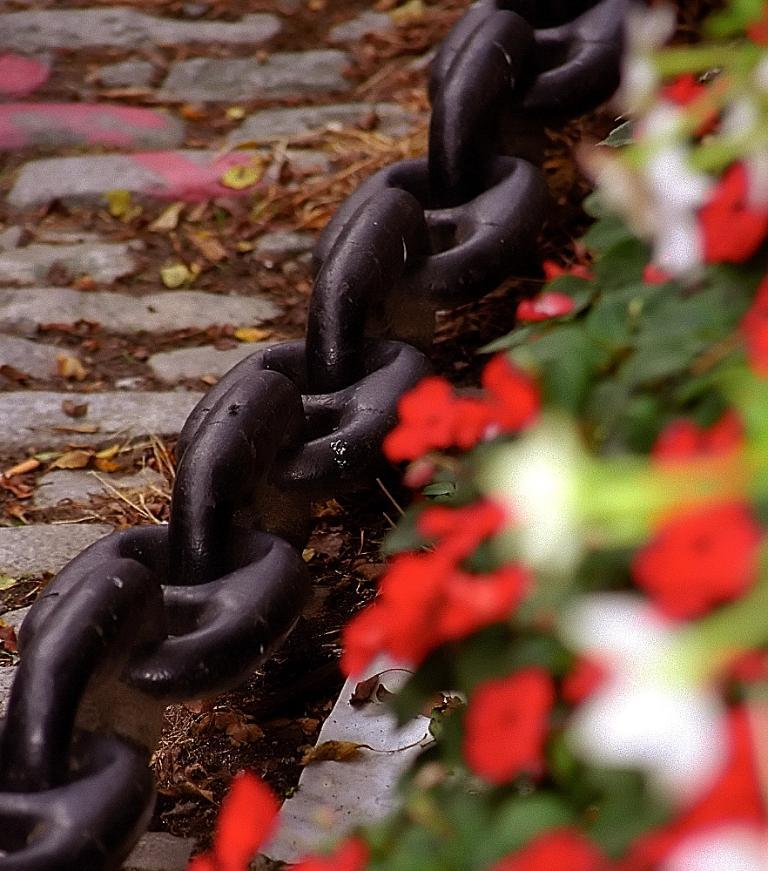What type of vegetation is on the right side of the image? There are flowers and leaves on the right side of the image. What objects can be seen in the center of the image? There are dry leaves and an iron chain in the center of the image. What type of surface is on the left side of the image? There is pavement on the left side of the image. How many eyes can be seen on the ground in the image? There are no eyes present in the image; it features flowers, leaves, dry leaves, an iron chain, and pavement. What type of clothing can be seen folding in the image? There is no clothing present in the image, nor is there any folding activity depicted. 